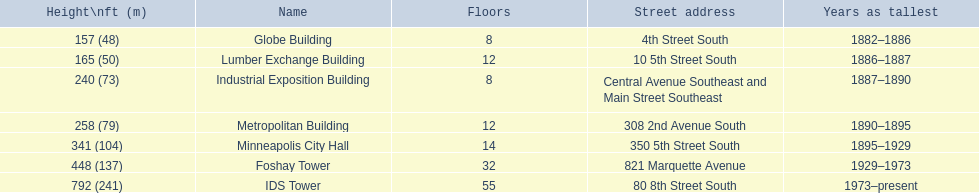How tall is the metropolitan building? 258 (79). How tall is the lumber exchange building? 165 (50). Is the metropolitan or lumber exchange building taller? Metropolitan Building. 